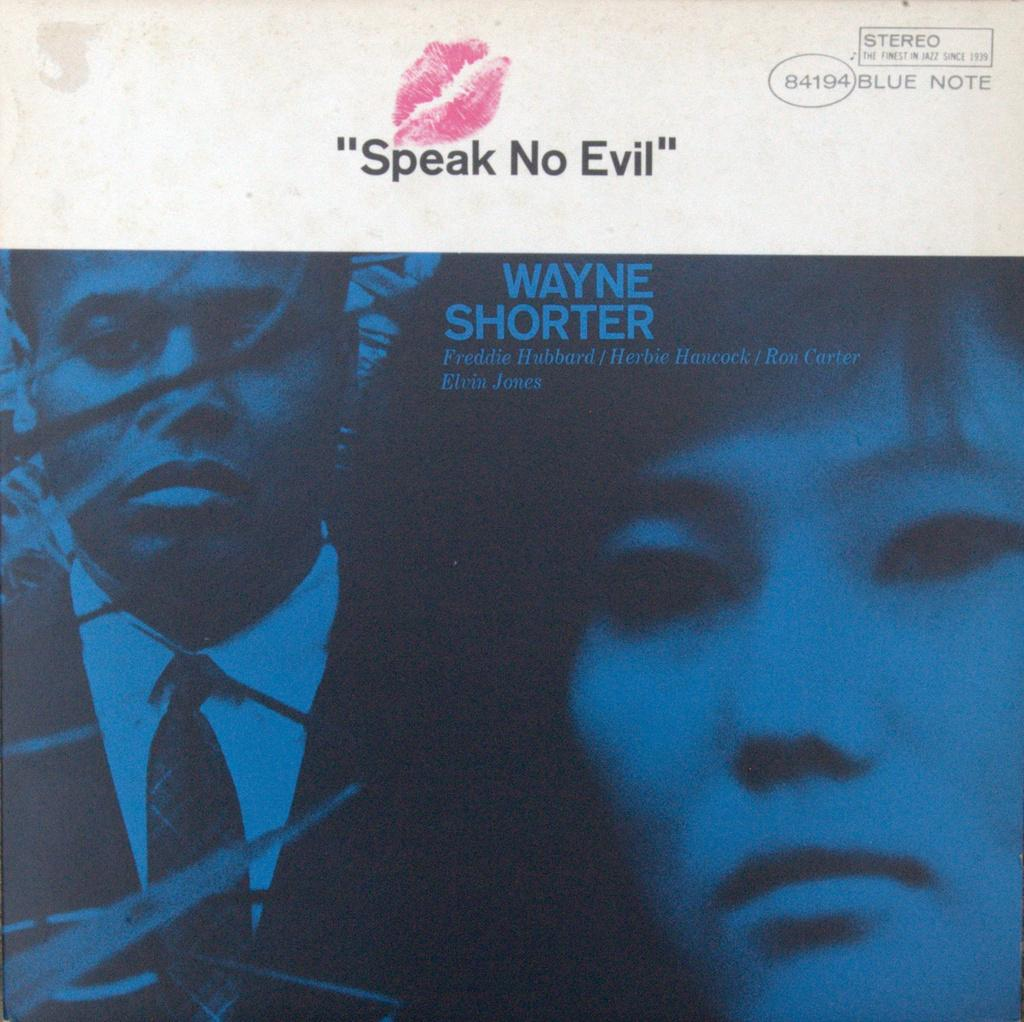What is the main object in the image? There is a poster in the image. What types of information are present on the poster? The poster contains words, numbers, and an image of two persons. Can you describe the mark on the poster? There is a lipstick mark on the poster. What type of office furniture can be seen in the image? There is no office furniture present in the image; it only features a poster with various elements. Can you describe the parent-child relationship depicted in the image? There is no parent or child depicted in the image; the poster contains an image of two persons, but their relationship is not specified. 